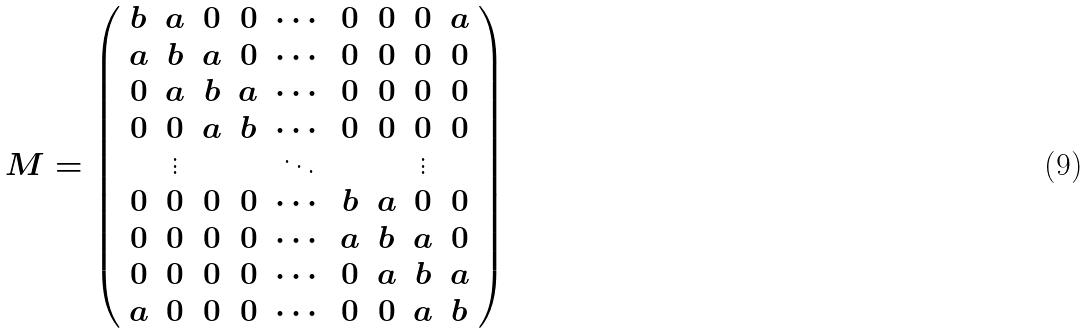<formula> <loc_0><loc_0><loc_500><loc_500>M = \left ( \begin{array} { c c c c c c c c c } b & a & 0 & 0 & \cdots & 0 & 0 & 0 & a \\ a & b & a & 0 & \cdots & 0 & 0 & 0 & 0 \\ 0 & a & b & a & \cdots & 0 & 0 & 0 & 0 \\ 0 & 0 & a & b & \cdots & 0 & 0 & 0 & 0 \\ & \vdots & & & \ddots & & & \vdots & \\ 0 & 0 & 0 & 0 & \cdots & b & a & 0 & 0 \\ 0 & 0 & 0 & 0 & \cdots & a & b & a & 0 \\ 0 & 0 & 0 & 0 & \cdots & 0 & a & b & a \\ a & 0 & 0 & 0 & \cdots & 0 & 0 & a & b \end{array} \right )</formula> 